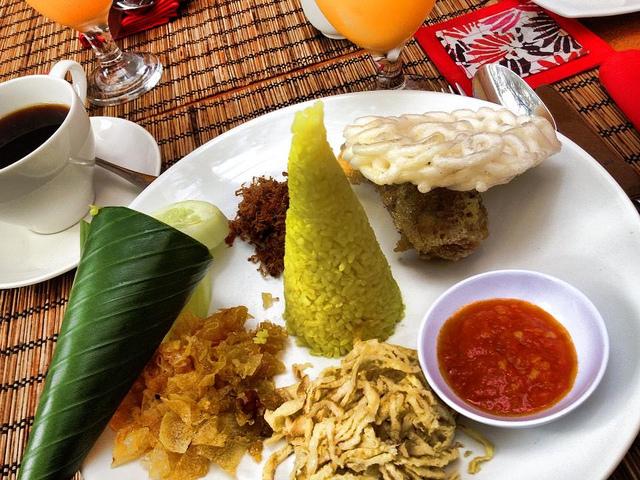What liquid is in the glass?
Be succinct. Coffee. How many components does this meal have?
Keep it brief. 8. Is this meal vegetarian?
Write a very short answer. Yes. Is the cup empty?
Be succinct. No. 